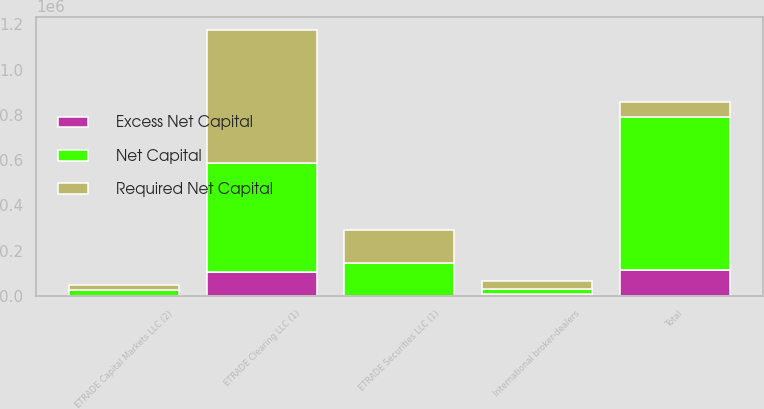<chart> <loc_0><loc_0><loc_500><loc_500><stacked_bar_chart><ecel><fcel>ETRADE Clearing LLC (1)<fcel>ETRADE Securities LLC (1)<fcel>ETRADE Capital Markets LLC (2)<fcel>International broker-dealers<fcel>Total<nl><fcel>Excess Net Capital<fcel>104804<fcel>250<fcel>1000<fcel>9183<fcel>115237<nl><fcel>Required Net Capital<fcel>587819<fcel>145423<fcel>24921<fcel>32157<fcel>68480.5<nl><fcel>Net Capital<fcel>483015<fcel>145173<fcel>23921<fcel>22974<fcel>675083<nl></chart> 